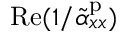<formula> <loc_0><loc_0><loc_500><loc_500>R e ( 1 / \tilde { \alpha } _ { x x } ^ { p } )</formula> 